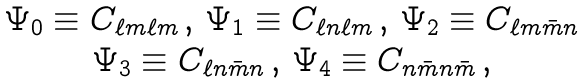<formula> <loc_0><loc_0><loc_500><loc_500>\begin{array} { c c } \Psi _ { 0 } \equiv C _ { \ell m \ell m } \, , \, \Psi _ { 1 } \equiv C _ { \ell n \ell m } \, , \, \Psi _ { 2 } \equiv C _ { \ell m \bar { m } n } \\ \Psi _ { 3 } \equiv C _ { \ell n \bar { m } n } \, , \, \Psi _ { 4 } \equiv C _ { n \bar { m } n \bar { m } } \, , \end{array}</formula> 